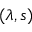Convert formula to latex. <formula><loc_0><loc_0><loc_500><loc_500>( \lambda , s )</formula> 